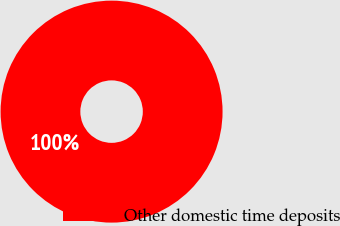Convert chart. <chart><loc_0><loc_0><loc_500><loc_500><pie_chart><fcel>Other domestic time deposits<nl><fcel>100.0%<nl></chart> 